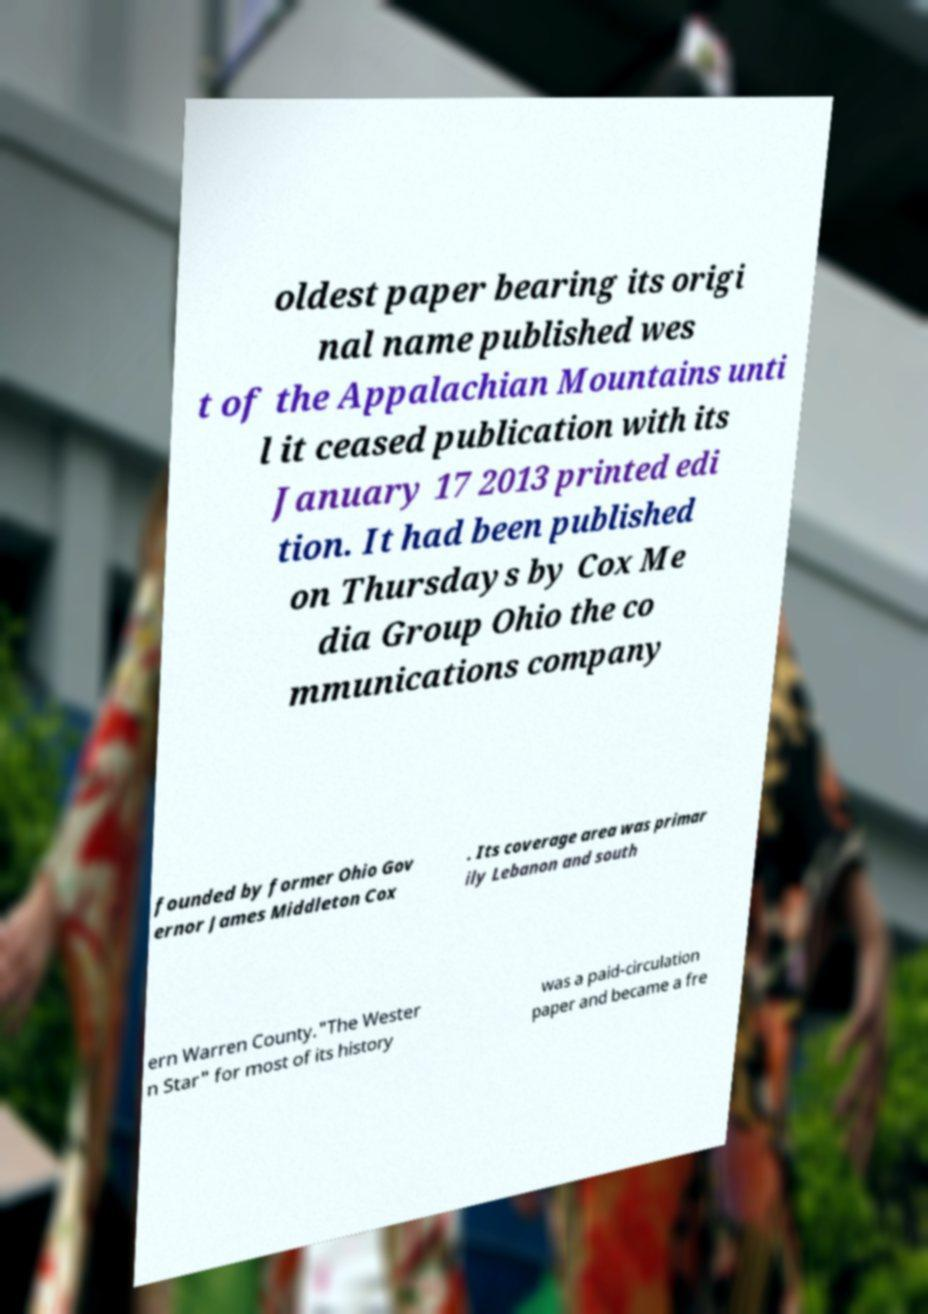I need the written content from this picture converted into text. Can you do that? oldest paper bearing its origi nal name published wes t of the Appalachian Mountains unti l it ceased publication with its January 17 2013 printed edi tion. It had been published on Thursdays by Cox Me dia Group Ohio the co mmunications company founded by former Ohio Gov ernor James Middleton Cox . Its coverage area was primar ily Lebanon and south ern Warren County."The Wester n Star" for most of its history was a paid-circulation paper and became a fre 